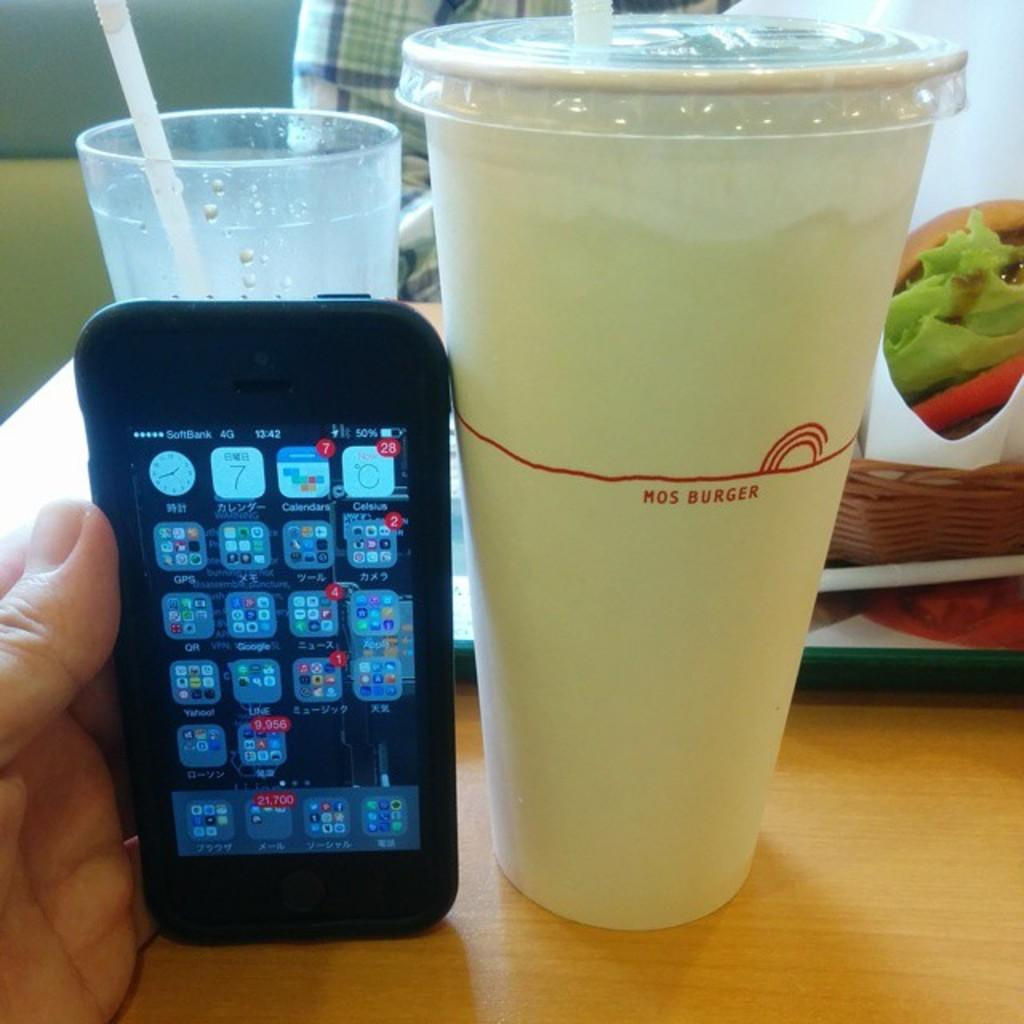<image>
Render a clear and concise summary of the photo. a drink with the word burger on it 